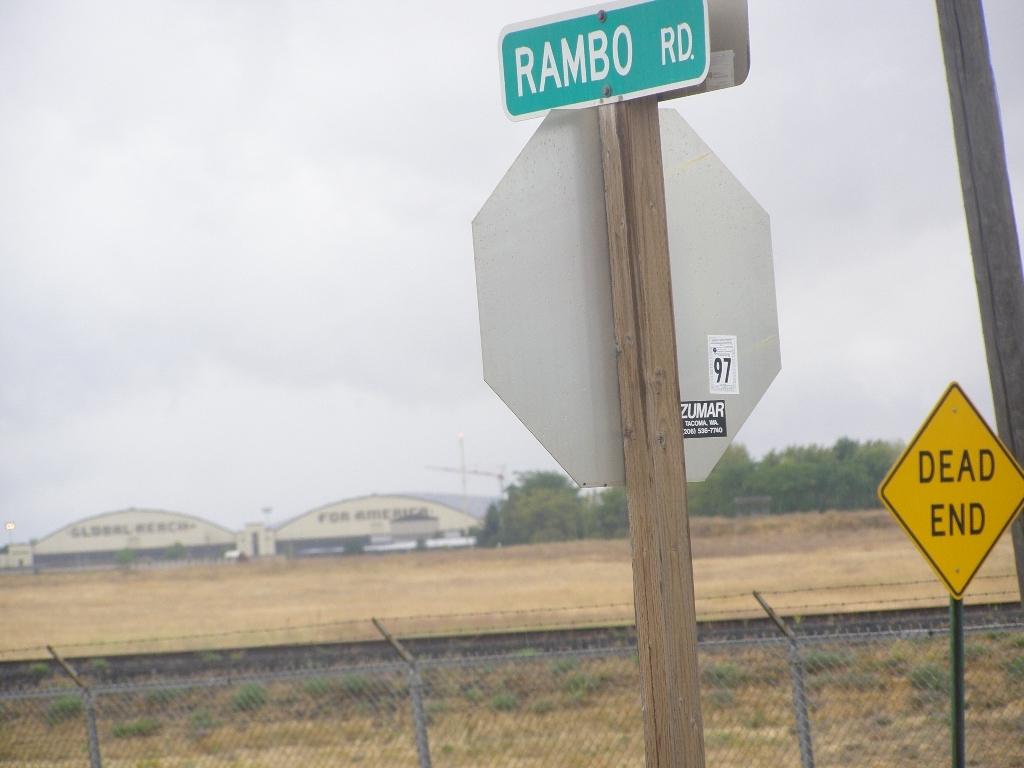What is the name of the street?
Your response must be concise. Rambo rd. What number is on the back of the stop sign?
Provide a succinct answer. 97. 